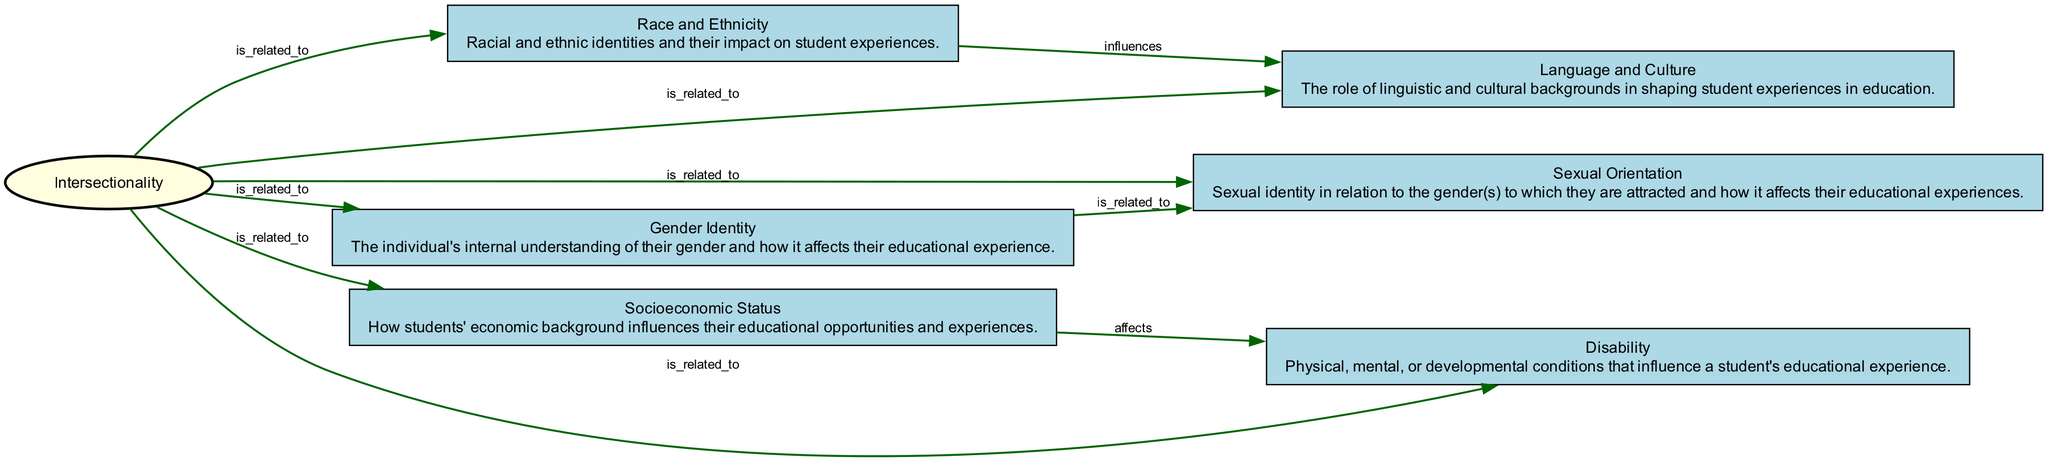What is the central concept in this diagram? The central concept node is "Intersectionality," which is indicated prominently and represents the main idea of the diagram.
Answer: Intersectionality How many nodes are present in the diagram? By counting all the nodes listed in the data, we find there are 7 nodes in total related to intersectionality and student experiences.
Answer: 7 Which node is directly linked to "Socioeconomic Status"? "Disability" is the node directly connected to "Socioeconomic Status," as indicated by the arrow showing their relationship in the diagram.
Answer: Disability What type of relationship exists between "Gender Identity" and "Sexual Orientation"? The relationship type between these two nodes is labeled as "is related to," which signifies a connection of influence or relevance in the context of student experiences.
Answer: is related to Which factors influence the student's language and cultural experiences according to the diagram? "Race and Ethnicity" influences "Language and Culture," showing a flow from one aspect of identity to another in shaping student experiences.
Answer: Race and Ethnicity Explain how "Disability" connects with "Socioeconomic Status" in terms of their relationship. The diagram specifies that "Socioeconomic Status" affects "Disability," indicating that the economic background of a student can impact their experiences concerning disability.
Answer: affects List all the identity aspects associated with the concept of "Intersectionality" in this diagram. The aspects associated with "Intersectionality" include "Race and Ethnicity," "Gender Identity," "Socioeconomic Status," "Disability," "Sexual Orientation," and "Language and Culture," indicating a broad range of identities.
Answer: Race and Ethnicity, Gender Identity, Socioeconomic Status, Disability, Sexual Orientation, Language and Culture What does the connection between "Race and Ethnicity" and "Language and Culture" signify? The connection signifies an influence where race and ethnicity shape a student's language and cultural experiences, demonstrating the interplay of these identities within education.
Answer: influences 